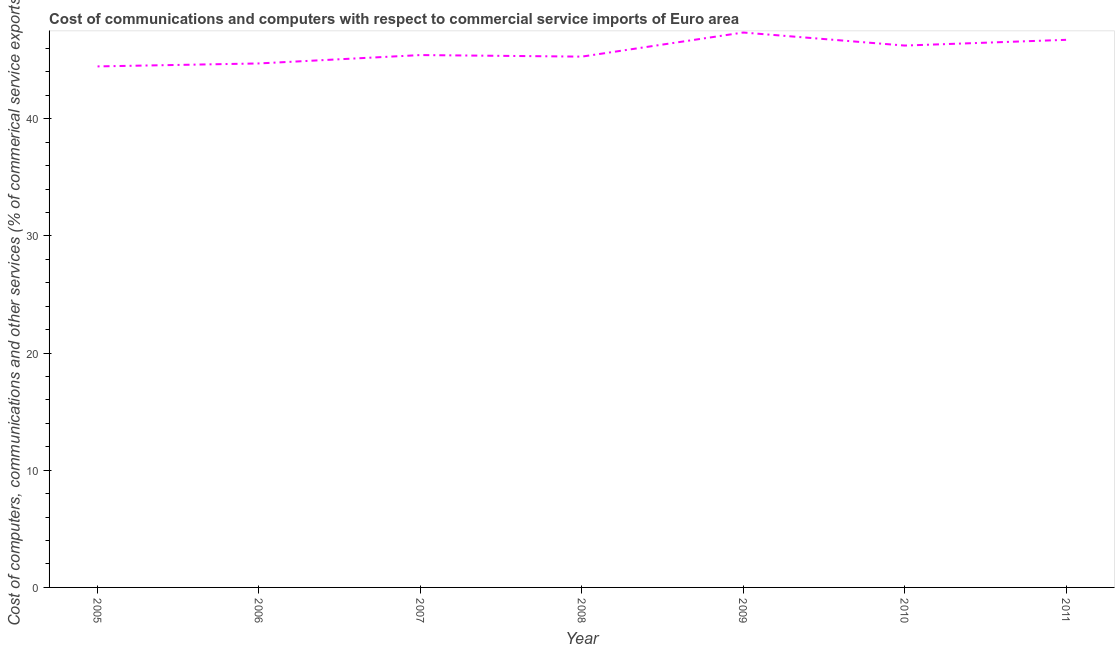What is the  computer and other services in 2010?
Provide a short and direct response. 46.25. Across all years, what is the maximum cost of communications?
Offer a very short reply. 47.36. Across all years, what is the minimum cost of communications?
Give a very brief answer. 44.47. What is the sum of the  computer and other services?
Provide a short and direct response. 320.26. What is the difference between the cost of communications in 2005 and 2010?
Your answer should be very brief. -1.78. What is the average  computer and other services per year?
Provide a short and direct response. 45.75. What is the median  computer and other services?
Your answer should be compact. 45.43. In how many years, is the cost of communications greater than 14 %?
Provide a succinct answer. 7. Do a majority of the years between 2010 and 2005 (inclusive) have  computer and other services greater than 38 %?
Your answer should be compact. Yes. What is the ratio of the  computer and other services in 2009 to that in 2011?
Your answer should be compact. 1.01. Is the  computer and other services in 2006 less than that in 2010?
Provide a short and direct response. Yes. What is the difference between the highest and the second highest  computer and other services?
Provide a succinct answer. 0.62. Is the sum of the cost of communications in 2008 and 2009 greater than the maximum cost of communications across all years?
Offer a terse response. Yes. What is the difference between the highest and the lowest cost of communications?
Keep it short and to the point. 2.89. Does the cost of communications monotonically increase over the years?
Keep it short and to the point. No. How many lines are there?
Ensure brevity in your answer.  1. What is the difference between two consecutive major ticks on the Y-axis?
Offer a terse response. 10. What is the title of the graph?
Your answer should be very brief. Cost of communications and computers with respect to commercial service imports of Euro area. What is the label or title of the Y-axis?
Your answer should be very brief. Cost of computers, communications and other services (% of commerical service exports). What is the Cost of computers, communications and other services (% of commerical service exports) in 2005?
Your answer should be compact. 44.47. What is the Cost of computers, communications and other services (% of commerical service exports) in 2006?
Give a very brief answer. 44.72. What is the Cost of computers, communications and other services (% of commerical service exports) in 2007?
Offer a very short reply. 45.43. What is the Cost of computers, communications and other services (% of commerical service exports) of 2008?
Give a very brief answer. 45.3. What is the Cost of computers, communications and other services (% of commerical service exports) in 2009?
Give a very brief answer. 47.36. What is the Cost of computers, communications and other services (% of commerical service exports) in 2010?
Provide a succinct answer. 46.25. What is the Cost of computers, communications and other services (% of commerical service exports) in 2011?
Provide a short and direct response. 46.73. What is the difference between the Cost of computers, communications and other services (% of commerical service exports) in 2005 and 2006?
Give a very brief answer. -0.25. What is the difference between the Cost of computers, communications and other services (% of commerical service exports) in 2005 and 2007?
Ensure brevity in your answer.  -0.97. What is the difference between the Cost of computers, communications and other services (% of commerical service exports) in 2005 and 2008?
Offer a very short reply. -0.83. What is the difference between the Cost of computers, communications and other services (% of commerical service exports) in 2005 and 2009?
Ensure brevity in your answer.  -2.89. What is the difference between the Cost of computers, communications and other services (% of commerical service exports) in 2005 and 2010?
Provide a succinct answer. -1.78. What is the difference between the Cost of computers, communications and other services (% of commerical service exports) in 2005 and 2011?
Your response must be concise. -2.27. What is the difference between the Cost of computers, communications and other services (% of commerical service exports) in 2006 and 2007?
Ensure brevity in your answer.  -0.71. What is the difference between the Cost of computers, communications and other services (% of commerical service exports) in 2006 and 2008?
Your answer should be compact. -0.58. What is the difference between the Cost of computers, communications and other services (% of commerical service exports) in 2006 and 2009?
Give a very brief answer. -2.64. What is the difference between the Cost of computers, communications and other services (% of commerical service exports) in 2006 and 2010?
Make the answer very short. -1.53. What is the difference between the Cost of computers, communications and other services (% of commerical service exports) in 2006 and 2011?
Ensure brevity in your answer.  -2.02. What is the difference between the Cost of computers, communications and other services (% of commerical service exports) in 2007 and 2008?
Your answer should be very brief. 0.13. What is the difference between the Cost of computers, communications and other services (% of commerical service exports) in 2007 and 2009?
Keep it short and to the point. -1.92. What is the difference between the Cost of computers, communications and other services (% of commerical service exports) in 2007 and 2010?
Provide a short and direct response. -0.81. What is the difference between the Cost of computers, communications and other services (% of commerical service exports) in 2007 and 2011?
Offer a very short reply. -1.3. What is the difference between the Cost of computers, communications and other services (% of commerical service exports) in 2008 and 2009?
Make the answer very short. -2.06. What is the difference between the Cost of computers, communications and other services (% of commerical service exports) in 2008 and 2010?
Your answer should be very brief. -0.94. What is the difference between the Cost of computers, communications and other services (% of commerical service exports) in 2008 and 2011?
Keep it short and to the point. -1.43. What is the difference between the Cost of computers, communications and other services (% of commerical service exports) in 2009 and 2010?
Offer a very short reply. 1.11. What is the difference between the Cost of computers, communications and other services (% of commerical service exports) in 2009 and 2011?
Offer a terse response. 0.62. What is the difference between the Cost of computers, communications and other services (% of commerical service exports) in 2010 and 2011?
Offer a terse response. -0.49. What is the ratio of the Cost of computers, communications and other services (% of commerical service exports) in 2005 to that in 2007?
Offer a terse response. 0.98. What is the ratio of the Cost of computers, communications and other services (% of commerical service exports) in 2005 to that in 2009?
Ensure brevity in your answer.  0.94. What is the ratio of the Cost of computers, communications and other services (% of commerical service exports) in 2005 to that in 2011?
Make the answer very short. 0.95. What is the ratio of the Cost of computers, communications and other services (% of commerical service exports) in 2006 to that in 2007?
Your answer should be very brief. 0.98. What is the ratio of the Cost of computers, communications and other services (% of commerical service exports) in 2006 to that in 2009?
Offer a terse response. 0.94. What is the ratio of the Cost of computers, communications and other services (% of commerical service exports) in 2006 to that in 2011?
Your answer should be compact. 0.96. What is the ratio of the Cost of computers, communications and other services (% of commerical service exports) in 2007 to that in 2008?
Make the answer very short. 1. What is the ratio of the Cost of computers, communications and other services (% of commerical service exports) in 2007 to that in 2010?
Your answer should be very brief. 0.98. What is the ratio of the Cost of computers, communications and other services (% of commerical service exports) in 2007 to that in 2011?
Provide a succinct answer. 0.97. What is the ratio of the Cost of computers, communications and other services (% of commerical service exports) in 2008 to that in 2010?
Offer a terse response. 0.98. What is the ratio of the Cost of computers, communications and other services (% of commerical service exports) in 2009 to that in 2010?
Provide a short and direct response. 1.02. 